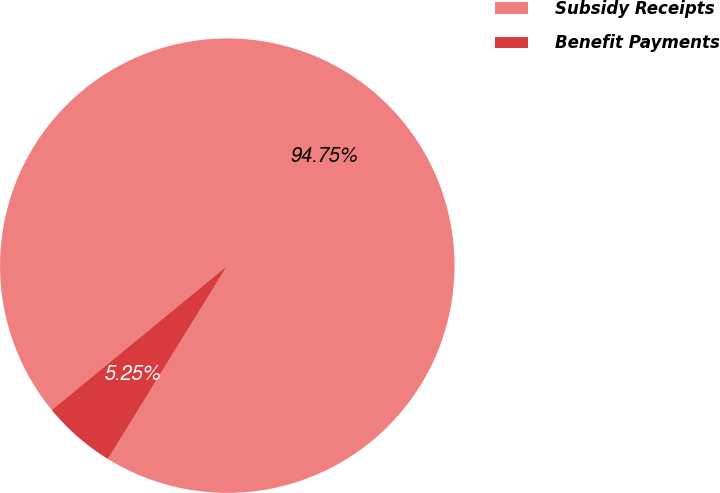Convert chart. <chart><loc_0><loc_0><loc_500><loc_500><pie_chart><fcel>Subsidy Receipts<fcel>Benefit Payments<nl><fcel>94.75%<fcel>5.25%<nl></chart> 